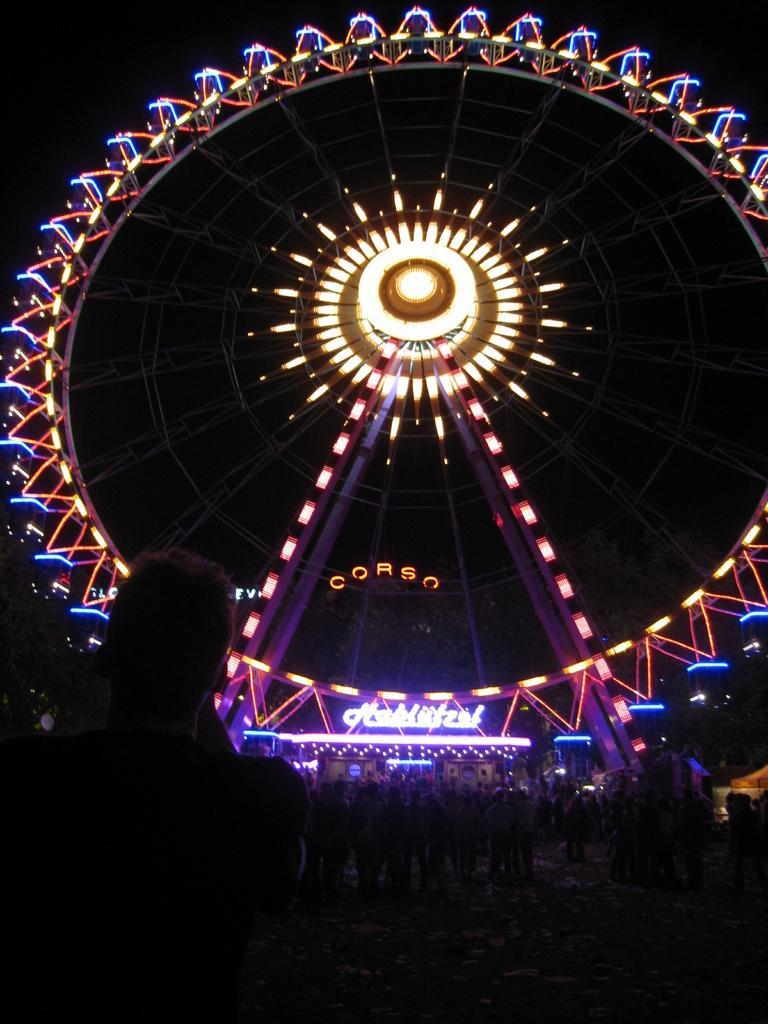Please provide a concise description of this image. There is a giant wheel with lights. In front of that there are many people. 